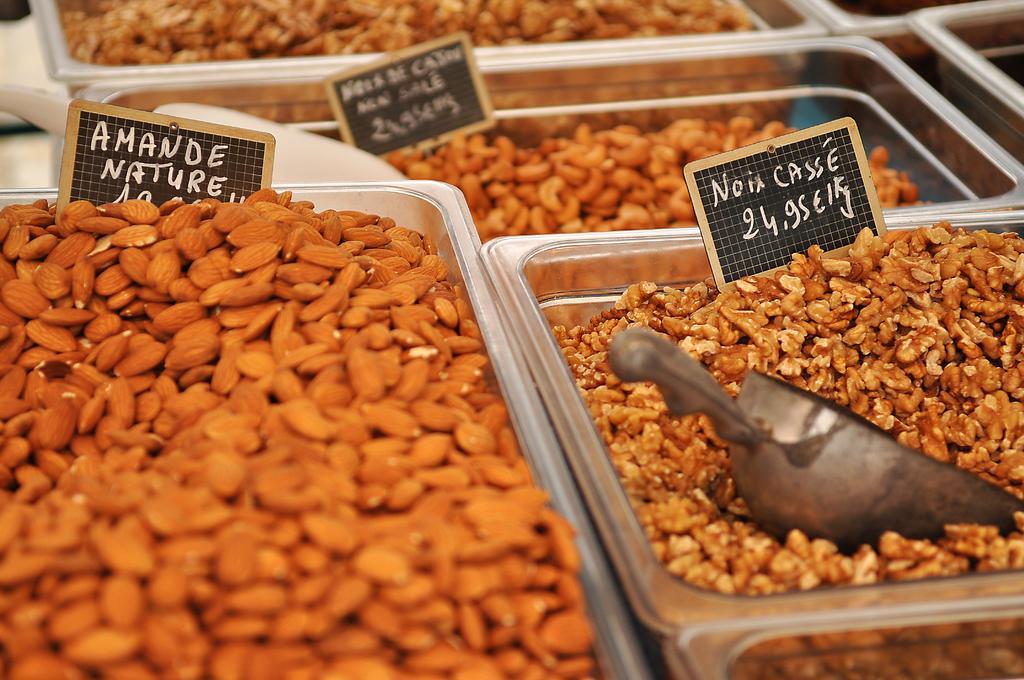Please provide a concise description of this image. In this image I can see few trays which are made up of metal in which I can see few dry fruits which are brown in color. I can see few boards which are black in color and a metal spoon. 